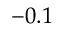Convert formula to latex. <formula><loc_0><loc_0><loc_500><loc_500>- 0 . 1</formula> 